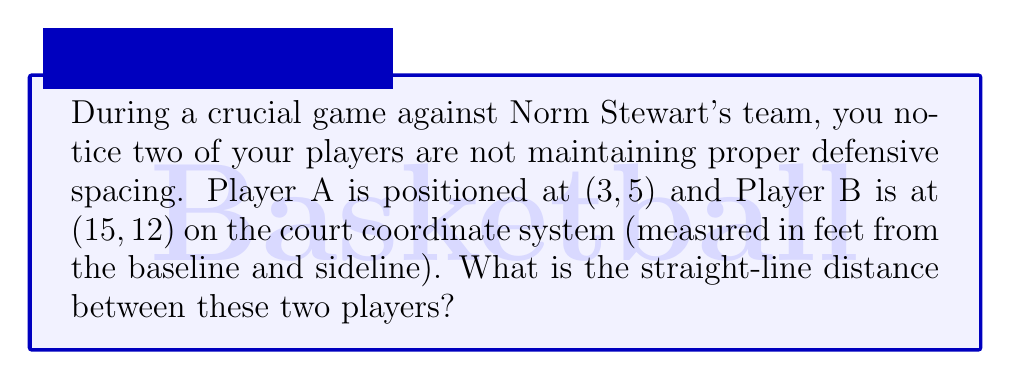Can you answer this question? To find the distance between two points on a coordinate plane, we can use the distance formula, which is derived from the Pythagorean theorem:

$$d = \sqrt{(x_2 - x_1)^2 + (y_2 - y_1)^2}$$

Where $(x_1, y_1)$ are the coordinates of the first point and $(x_2, y_2)$ are the coordinates of the second point.

Let's plug in our values:
Player A: $(x_1, y_1) = (3, 5)$
Player B: $(x_2, y_2) = (15, 12)$

Now, let's calculate:

$$\begin{align*}
d &= \sqrt{(15 - 3)^2 + (12 - 5)^2} \\
&= \sqrt{12^2 + 7^2} \\
&= \sqrt{144 + 49} \\
&= \sqrt{193} \\
&\approx 13.89 \text{ feet}
\end{align*}$$

[asy]
unitsize(10);
draw((0,0)--(20,0)--(20,15)--(0,15)--cycle);
dot((3,5),red);
dot((15,12),blue);
draw((3,5)--(15,12),dashed);
label("A",(3,5),SW,red);
label("B",(15,12),NE,blue);
label("13.89 ft",(9,8.5),SE);
[/asy]
Answer: $13.89$ feet 